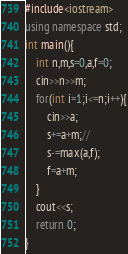<code> <loc_0><loc_0><loc_500><loc_500><_C++_>#include<iostream>
using namespace std;
int main(){
	int n,m,s=0,a,f=0;
	cin>>n>>m;
	for(int i=1;i<=n;i++){
		cin>>a;
		s+=a+m;//
		s-=max(a,f);
		f=a+m;
	}
	cout<<s;
	return 0;
}</code> 